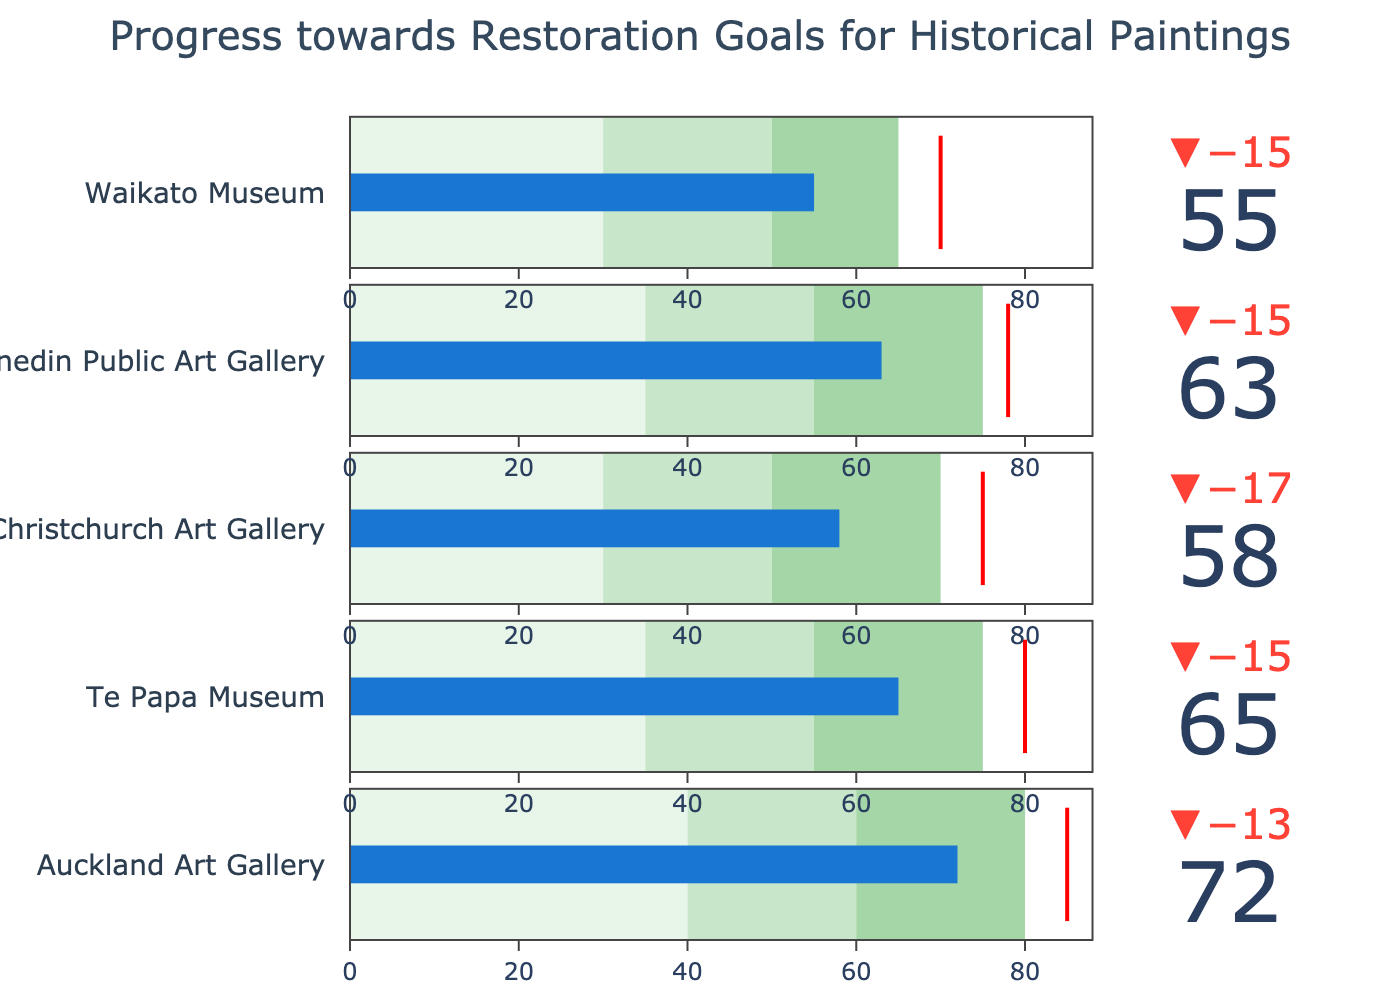What is the title of the chart? The title of the chart is typically displayed prominently at the top. In this figure, it reads "Progress towards Restoration Goals for Historical Paintings".
Answer: Progress towards Restoration Goals for Historical Paintings What museum shows the highest actual progress towards its target? To determine the highest actual progress, we compare the "Actual" values for each museum. Auckland Art Gallery has the highest "Actual" value at 72.
Answer: Auckland Art Gallery Which museum's progress is closest to its target? To find the closest progress, we look at the difference between "Actual" and "Target" for each museum. Auckland Art Gallery has the smallest difference (85 - 72 = 13).
Answer: Auckland Art Gallery What are the range values for Christchurch Art Gallery? The ranges are segmented within the bullet chart's bars and usually displayed near each bar. For Christchurch Art Gallery, these values are 30 (Range1), 50 (Range2), and 70 (Range3).
Answer: 30, 50, 70 Which museum has the smallest difference between Range3 and its Target? Calculate the differences between Range3 and Target for each museum. Christchurch Art Gallery has the smallest difference (75 - 70 = 5).
Answer: Christchurch Art Gallery What is the threshold value indicated by the red line in the bullet chart for Te Papa Museum? The threshold value, represented by the red line, corresponds to the "Target" value. For Te Papa Museum, it is 80.
Answer: 80 How many museums have an actual progress above 60? We count the "Actual" values that are above 60. Auckland Art Gallery, Te Papa Museum, Christchurch Art Gallery, and Dunedin Public Art Gallery have values above 60.
Answer: 4 What ranges indicate satisfactory progress for Dunedin Public Art Gallery in the bullet chart? The ranges, indicated by different shades of green or grey in the bullet chart, show progress levels. For Dunedin Public Art Gallery, satisfactory progress is indicated by values falling between Range1 and Range2 (35 to 55).
Answer: 35 to 55 Which museum is underperforming relative to its target by the largest amount? Assess the difference between "Target" and "Actual" values for each museum. Waikato Museum has the largest discrepancy (70 - 55 = 15).
Answer: Waikato Museum What overall trend does the bullet chart suggest about the progress towards restoration goals across the museums? From comparing "Actual" to "Target" values and the position within ranges, it indicates most museums are progressing but have not yet reached their targets. Auckland Art Gallery is the closest to its target, suggesting variable progress across institutions.
Answer: Variable progress, with some museums closer to targets than others 